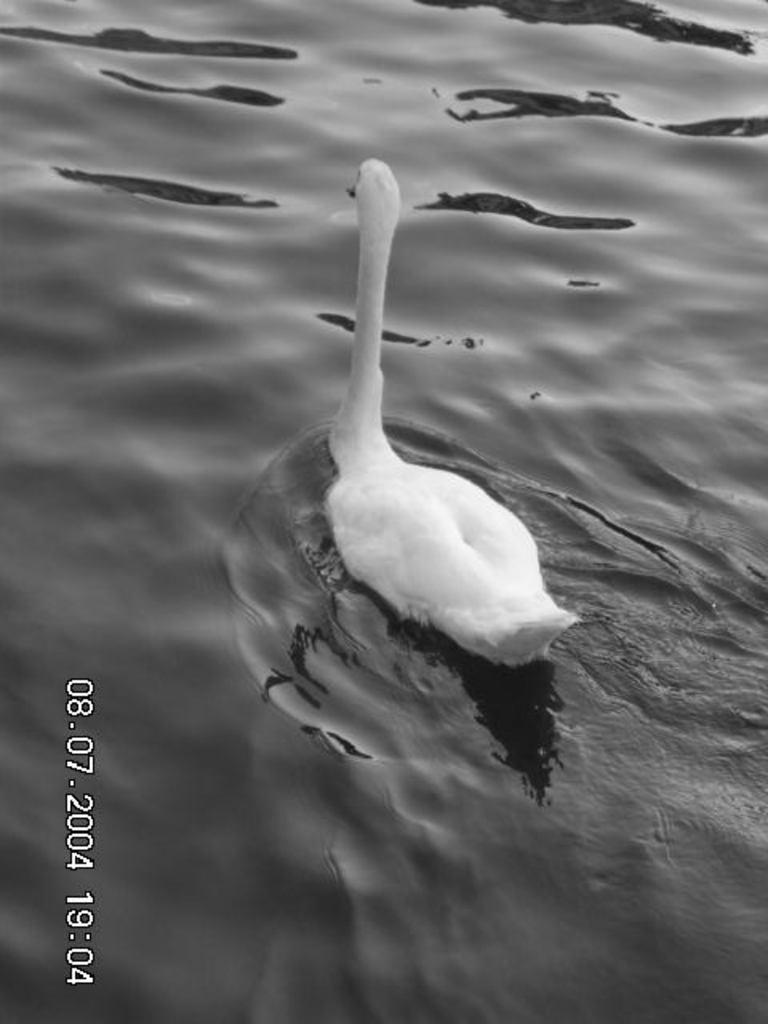What animal is present in the image? There is a swan in the image. What is the swan doing in the image? The swan is swimming on the water. What can be seen on the left side of the image? There are numbers on the left side of the image. Where are the ants located in the image? There are no ants present in the image. What type of key is being used by the swan in the image? There is no key present in the image, and the swan is not using any tool. 